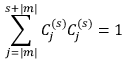<formula> <loc_0><loc_0><loc_500><loc_500>\sum _ { j = | m | } ^ { s + | m | } C _ { j } ^ { ( s ) } C _ { j } ^ { ( s ) } = 1</formula> 